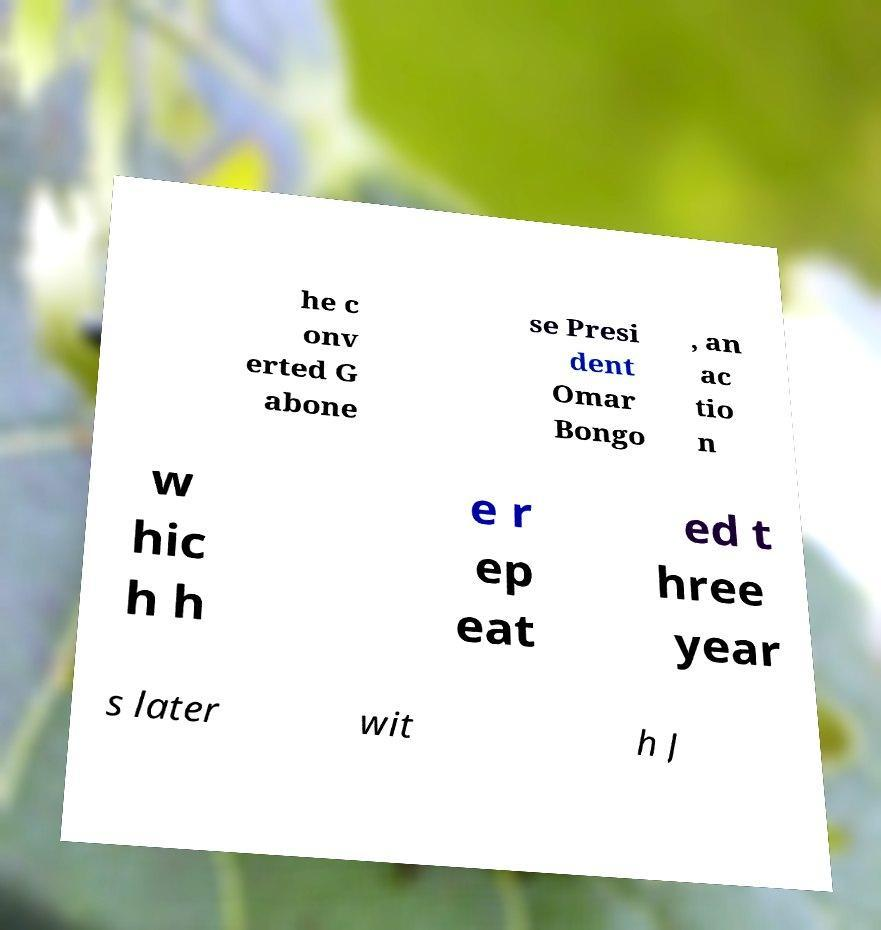Can you accurately transcribe the text from the provided image for me? he c onv erted G abone se Presi dent Omar Bongo , an ac tio n w hic h h e r ep eat ed t hree year s later wit h J 